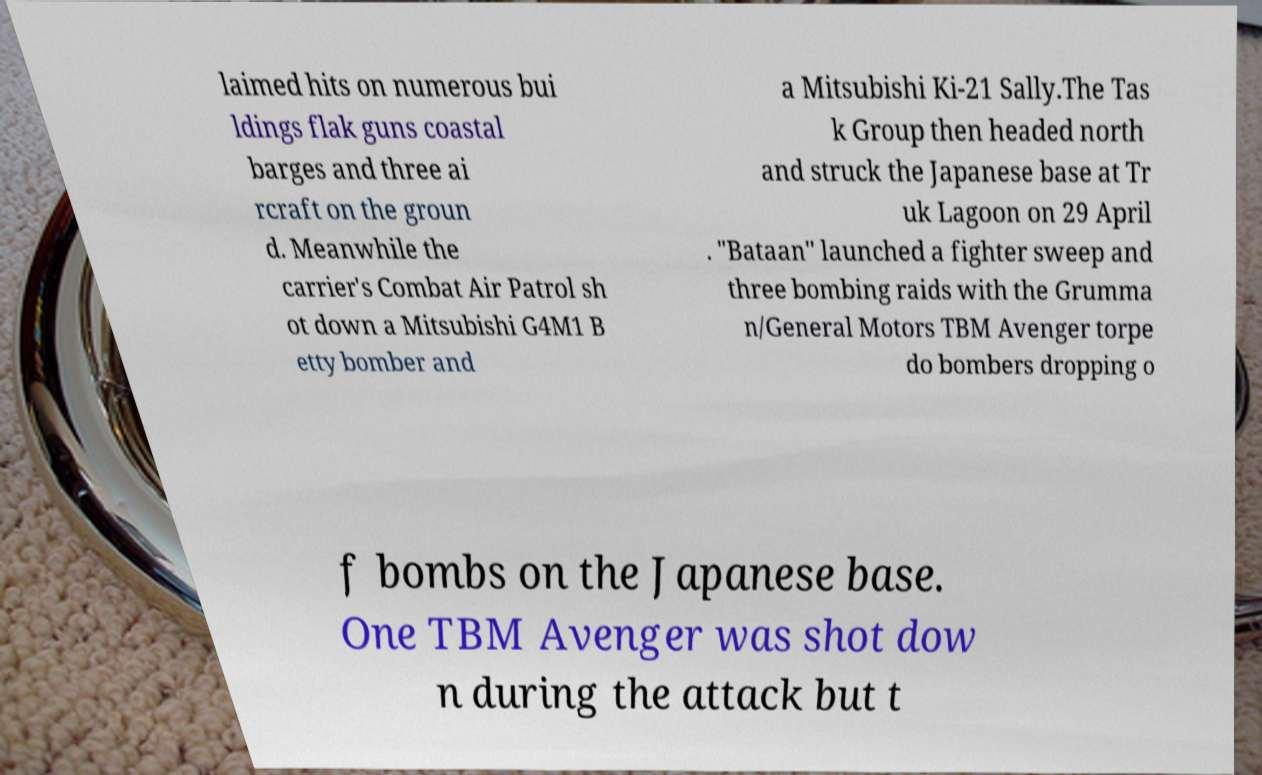For documentation purposes, I need the text within this image transcribed. Could you provide that? laimed hits on numerous bui ldings flak guns coastal barges and three ai rcraft on the groun d. Meanwhile the carrier's Combat Air Patrol sh ot down a Mitsubishi G4M1 B etty bomber and a Mitsubishi Ki-21 Sally.The Tas k Group then headed north and struck the Japanese base at Tr uk Lagoon on 29 April . "Bataan" launched a fighter sweep and three bombing raids with the Grumma n/General Motors TBM Avenger torpe do bombers dropping o f bombs on the Japanese base. One TBM Avenger was shot dow n during the attack but t 